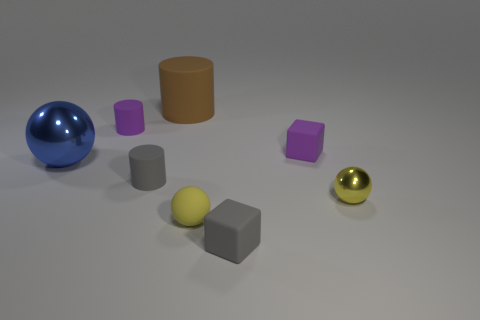Add 2 brown objects. How many objects exist? 10 Subtract all spheres. How many objects are left? 5 Subtract 1 gray blocks. How many objects are left? 7 Subtract all small matte cylinders. Subtract all purple blocks. How many objects are left? 5 Add 1 gray matte cylinders. How many gray matte cylinders are left? 2 Add 2 tiny rubber things. How many tiny rubber things exist? 7 